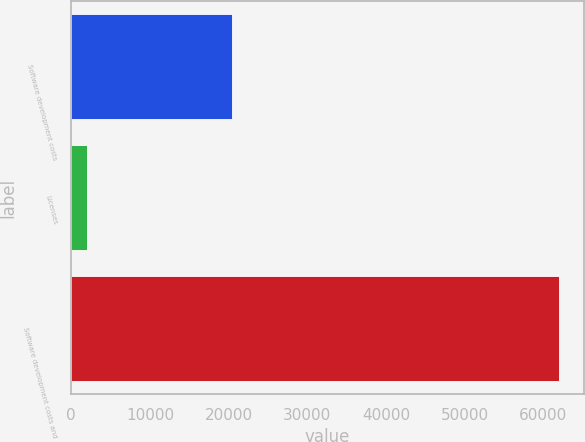Convert chart to OTSL. <chart><loc_0><loc_0><loc_500><loc_500><bar_chart><fcel>Software development costs<fcel>Licenses<fcel>Software development costs and<nl><fcel>20495<fcel>1988<fcel>61991<nl></chart> 